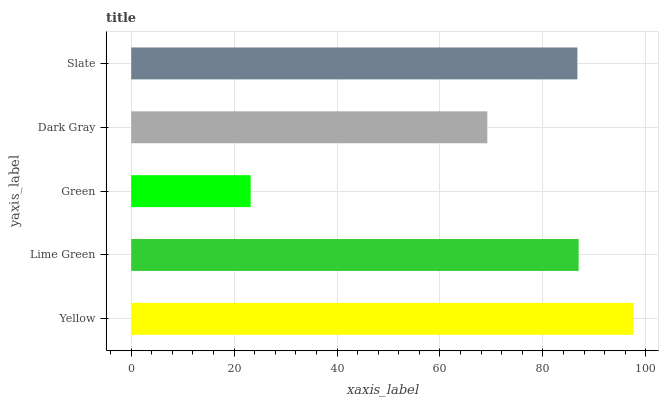Is Green the minimum?
Answer yes or no. Yes. Is Yellow the maximum?
Answer yes or no. Yes. Is Lime Green the minimum?
Answer yes or no. No. Is Lime Green the maximum?
Answer yes or no. No. Is Yellow greater than Lime Green?
Answer yes or no. Yes. Is Lime Green less than Yellow?
Answer yes or no. Yes. Is Lime Green greater than Yellow?
Answer yes or no. No. Is Yellow less than Lime Green?
Answer yes or no. No. Is Slate the high median?
Answer yes or no. Yes. Is Slate the low median?
Answer yes or no. Yes. Is Yellow the high median?
Answer yes or no. No. Is Lime Green the low median?
Answer yes or no. No. 